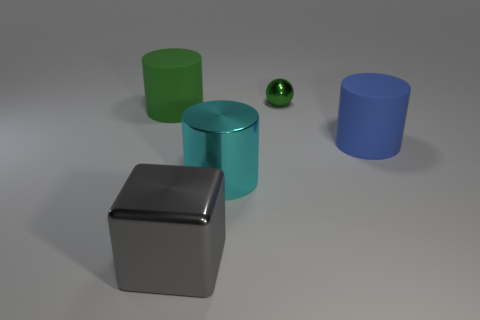There is another big matte thing that is the same shape as the large blue matte thing; what is its color?
Your answer should be very brief. Green. There is a thing that is behind the big cyan metal thing and on the left side of the small green shiny sphere; what is its material?
Ensure brevity in your answer.  Rubber. Do the large cylinder that is to the left of the gray block and the green object on the right side of the large green thing have the same material?
Offer a very short reply. No. The green shiny thing has what size?
Ensure brevity in your answer.  Small. There is a large cyan object; how many large rubber objects are to the right of it?
Ensure brevity in your answer.  1. The object that is behind the large matte object that is left of the big blue thing is what color?
Provide a succinct answer. Green. Is there anything else that has the same shape as the cyan object?
Give a very brief answer. Yes. Is the number of big blue matte cylinders that are in front of the large gray metallic object the same as the number of green objects left of the big cyan object?
Your response must be concise. No. What number of blocks are tiny purple objects or green rubber objects?
Your answer should be compact. 0. How many other objects are there of the same material as the big green cylinder?
Offer a very short reply. 1. 